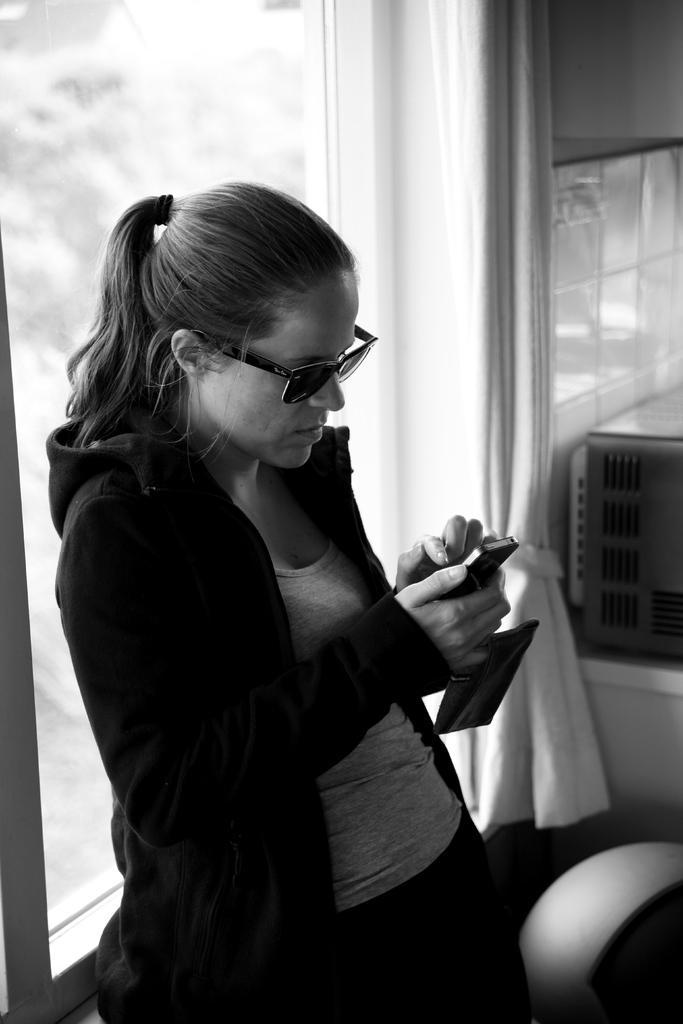Could you give a brief overview of what you see in this image? A black and white picture. This woman wore jacket, goggles and looking at her mobile. Backside of this woman there is a window. This is curtain. 